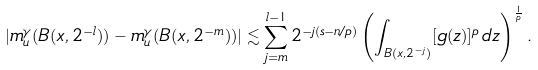<formula> <loc_0><loc_0><loc_500><loc_500>| m _ { u } ^ { \gamma } ( B ( x , 2 ^ { - l } ) ) - m _ { u } ^ { \gamma } ( B ( x , 2 ^ { - m } ) ) | \lesssim \sum _ { j = m } ^ { l - 1 } 2 ^ { - j ( s - n / p ) } \left ( \int _ { B ( x , 2 ^ { - j } ) } [ g ( z ) ] ^ { p } \, d z \right ) ^ { \frac { 1 } { p } } .</formula> 